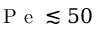<formula> <loc_0><loc_0><loc_500><loc_500>P e \lesssim 5 0</formula> 